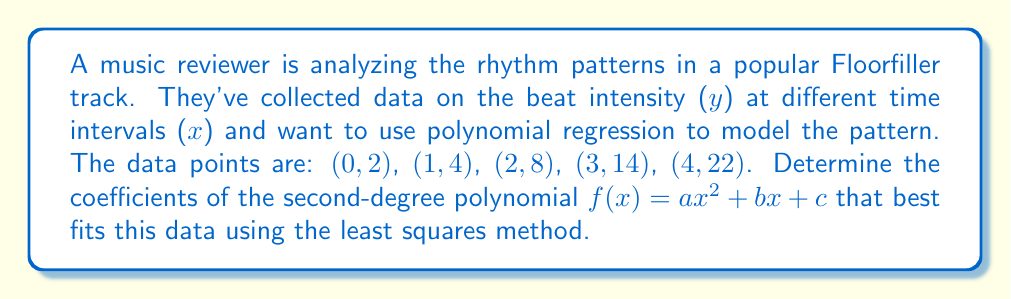Could you help me with this problem? To find the coefficients of the second-degree polynomial using the least squares method, we need to solve the following system of equations:

$$\begin{align}
\sum y &= an\sum x^2 + bn\sum x + cn \\
\sum xy &= a\sum x^3 + b\sum x^2 + c\sum x \\
\sum x^2y &= a\sum x^4 + b\sum x^3 + c\sum x^2
\end{align}$$

Step 1: Calculate the sums needed for the equations:
$n = 5$
$\sum x = 0 + 1 + 2 + 3 + 4 = 10$
$\sum x^2 = 0^2 + 1^2 + 2^2 + 3^2 + 4^2 = 30$
$\sum x^3 = 0^3 + 1^3 + 2^3 + 3^3 + 4^3 = 100$
$\sum x^4 = 0^4 + 1^4 + 2^4 + 3^4 + 4^4 = 354$
$\sum y = 2 + 4 + 8 + 14 + 22 = 50$
$\sum xy = 0(2) + 1(4) + 2(8) + 3(14) + 4(22) = 140$
$\sum x^2y = 0^2(2) + 1^2(4) + 2^2(8) + 3^2(14) + 4^2(22) = 454$

Step 2: Substitute these values into the system of equations:

$$\begin{align}
50 &= 30a + 10b + 5c \\
140 &= 100a + 30b + 10c \\
454 &= 354a + 100b + 30c
\end{align}$$

Step 3: Solve this system of equations using elimination or matrix methods. After solving, we get:

$a = 1$
$b = 1$
$c = 2$

Therefore, the second-degree polynomial that best fits the data is $f(x) = x^2 + x + 2$.
Answer: $f(x) = x^2 + x + 2$ 